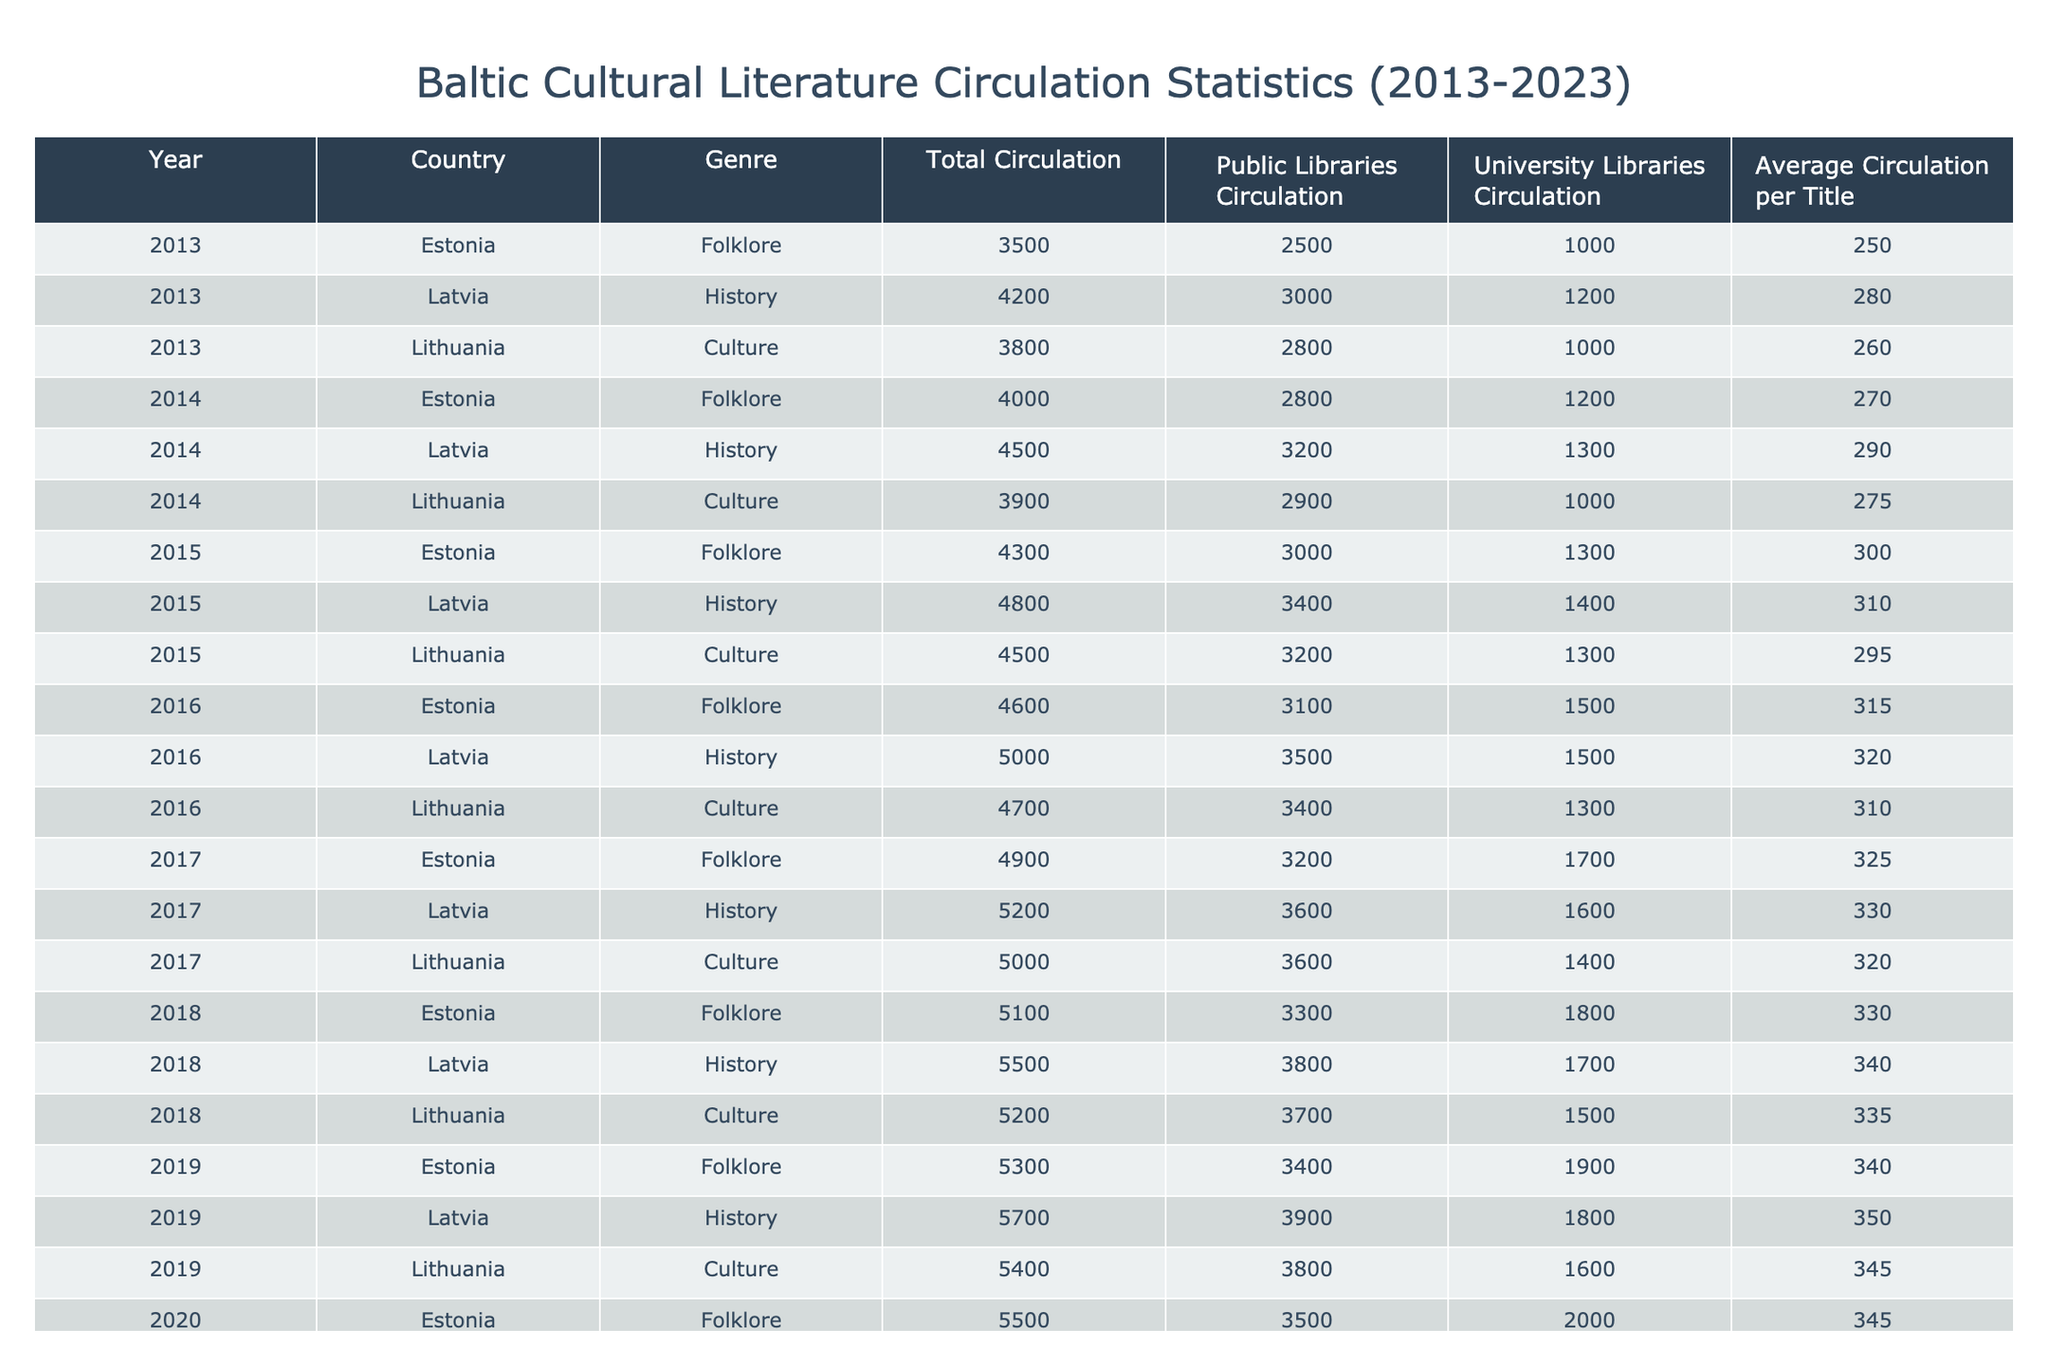What was the total circulation of folklore literature in Estonia in 2015? In the table, we look under the year 2015 and find Estonia's row for the genre 'Folklore.' The value under 'Total Circulation' for that entry is 4300.
Answer: 4300 Which country had the highest circulation of history literature in 2022? By examining the table for the year 2022, we check the 'Total Circulation' under the 'History' genre for each country: Latvia: 6300, Estonia: 5900, Lithuania: 6000. Latvia has the highest value at 6300.
Answer: Latvia What was the average circulation per title of culture literature in Lithuania across the decade? To find the average, we sum the 'Average Circulation per Title' values for Lithuania's culture literature from 2013 to 2023, which are 260, 275, 295, 310, 320, 335, 345, 350, 355, and 360. The total is 3190, and there are 10 years, so average = 3190/10 = 319.
Answer: 319 Is there a year in which Estonia's total circulation for folklore literature decreased compared to the previous year? Checking the total circulation values for Estonia's folklore across the years: 3500, 4000, 4300, 4600, 4900, 5100, 5300, 5500, 5700, 5900, 6100 shows that there's no decrease at any point; each year it increased.
Answer: No Which genre had the most significant increase in total circulation in Latvia from 2013 to 2023? For Latvia, we track the 'Total Circulation' from 2013 (4200) to 2023 (6500) across genres. The increases are: History: 6500 - 4200 = 2300, Folklore and Culture don't have data in this range, confirming history is the only option with an increase of 2300.
Answer: History What was the combined total circulation for folklore literature in Estonia from 2013 to 2023? We sum the total circulations for all years of folklore literature in Estonia: 3500 + 4000 + 4300 + 4600 + 4900 + 5100 + 5300 + 5500 + 5700 + 5900 + 6100 =  55400.
Answer: 55400 